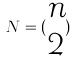Convert formula to latex. <formula><loc_0><loc_0><loc_500><loc_500>N = ( \begin{matrix} n \\ 2 \end{matrix} )</formula> 